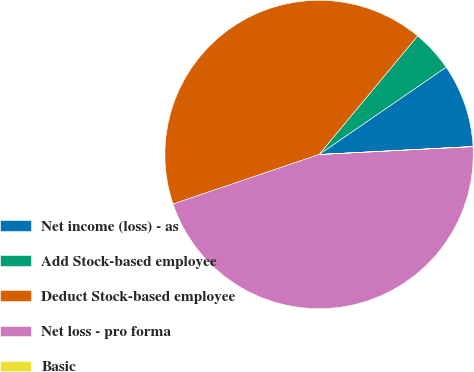Convert chart. <chart><loc_0><loc_0><loc_500><loc_500><pie_chart><fcel>Net income (loss) - as<fcel>Add Stock-based employee<fcel>Deduct Stock-based employee<fcel>Net loss - pro forma<fcel>Basic<nl><fcel>8.76%<fcel>4.38%<fcel>41.24%<fcel>45.61%<fcel>0.01%<nl></chart> 